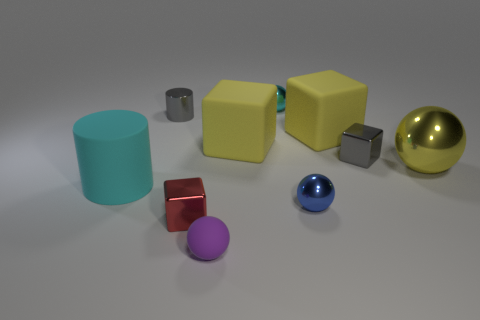Is the cyan rubber thing the same shape as the big metal thing?
Offer a very short reply. No. There is a sphere that is in front of the small block to the left of the tiny purple rubber object; what is it made of?
Your answer should be very brief. Rubber. There is a tiny object that is the same color as the tiny metal cylinder; what is its material?
Offer a terse response. Metal. Is the yellow metallic object the same size as the cyan cylinder?
Give a very brief answer. Yes. Are there any cylinders that are behind the matte block right of the small cyan metal sphere?
Your response must be concise. Yes. There is a blue metallic thing that is on the right side of the small purple ball; what is its shape?
Provide a short and direct response. Sphere. There is a yellow rubber object that is right of the ball that is behind the tiny gray shiny cube; how many spheres are in front of it?
Provide a succinct answer. 3. Is the size of the rubber sphere the same as the block that is in front of the big cyan matte object?
Give a very brief answer. Yes. What is the size of the cyan thing that is on the left side of the tiny gray thing that is on the left side of the purple ball?
Your response must be concise. Large. What number of tiny green balls are made of the same material as the big cyan object?
Keep it short and to the point. 0. 